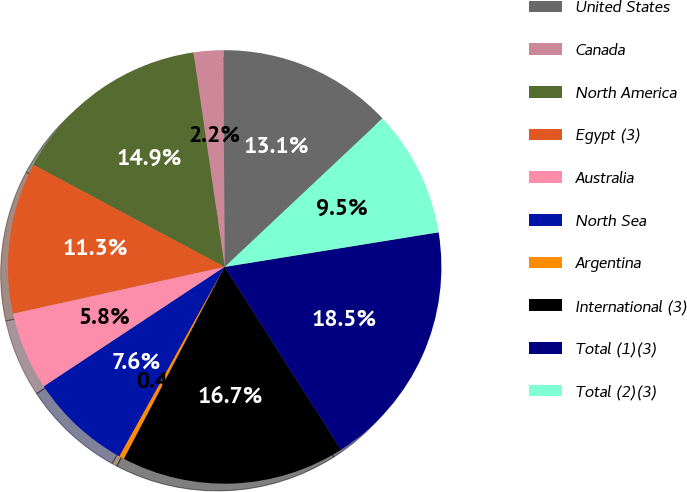Convert chart to OTSL. <chart><loc_0><loc_0><loc_500><loc_500><pie_chart><fcel>United States<fcel>Canada<fcel>North America<fcel>Egypt (3)<fcel>Australia<fcel>North Sea<fcel>Argentina<fcel>International (3)<fcel>Total (1)(3)<fcel>Total (2)(3)<nl><fcel>13.09%<fcel>2.2%<fcel>14.9%<fcel>11.27%<fcel>5.83%<fcel>7.64%<fcel>0.38%<fcel>16.72%<fcel>18.53%<fcel>9.46%<nl></chart> 